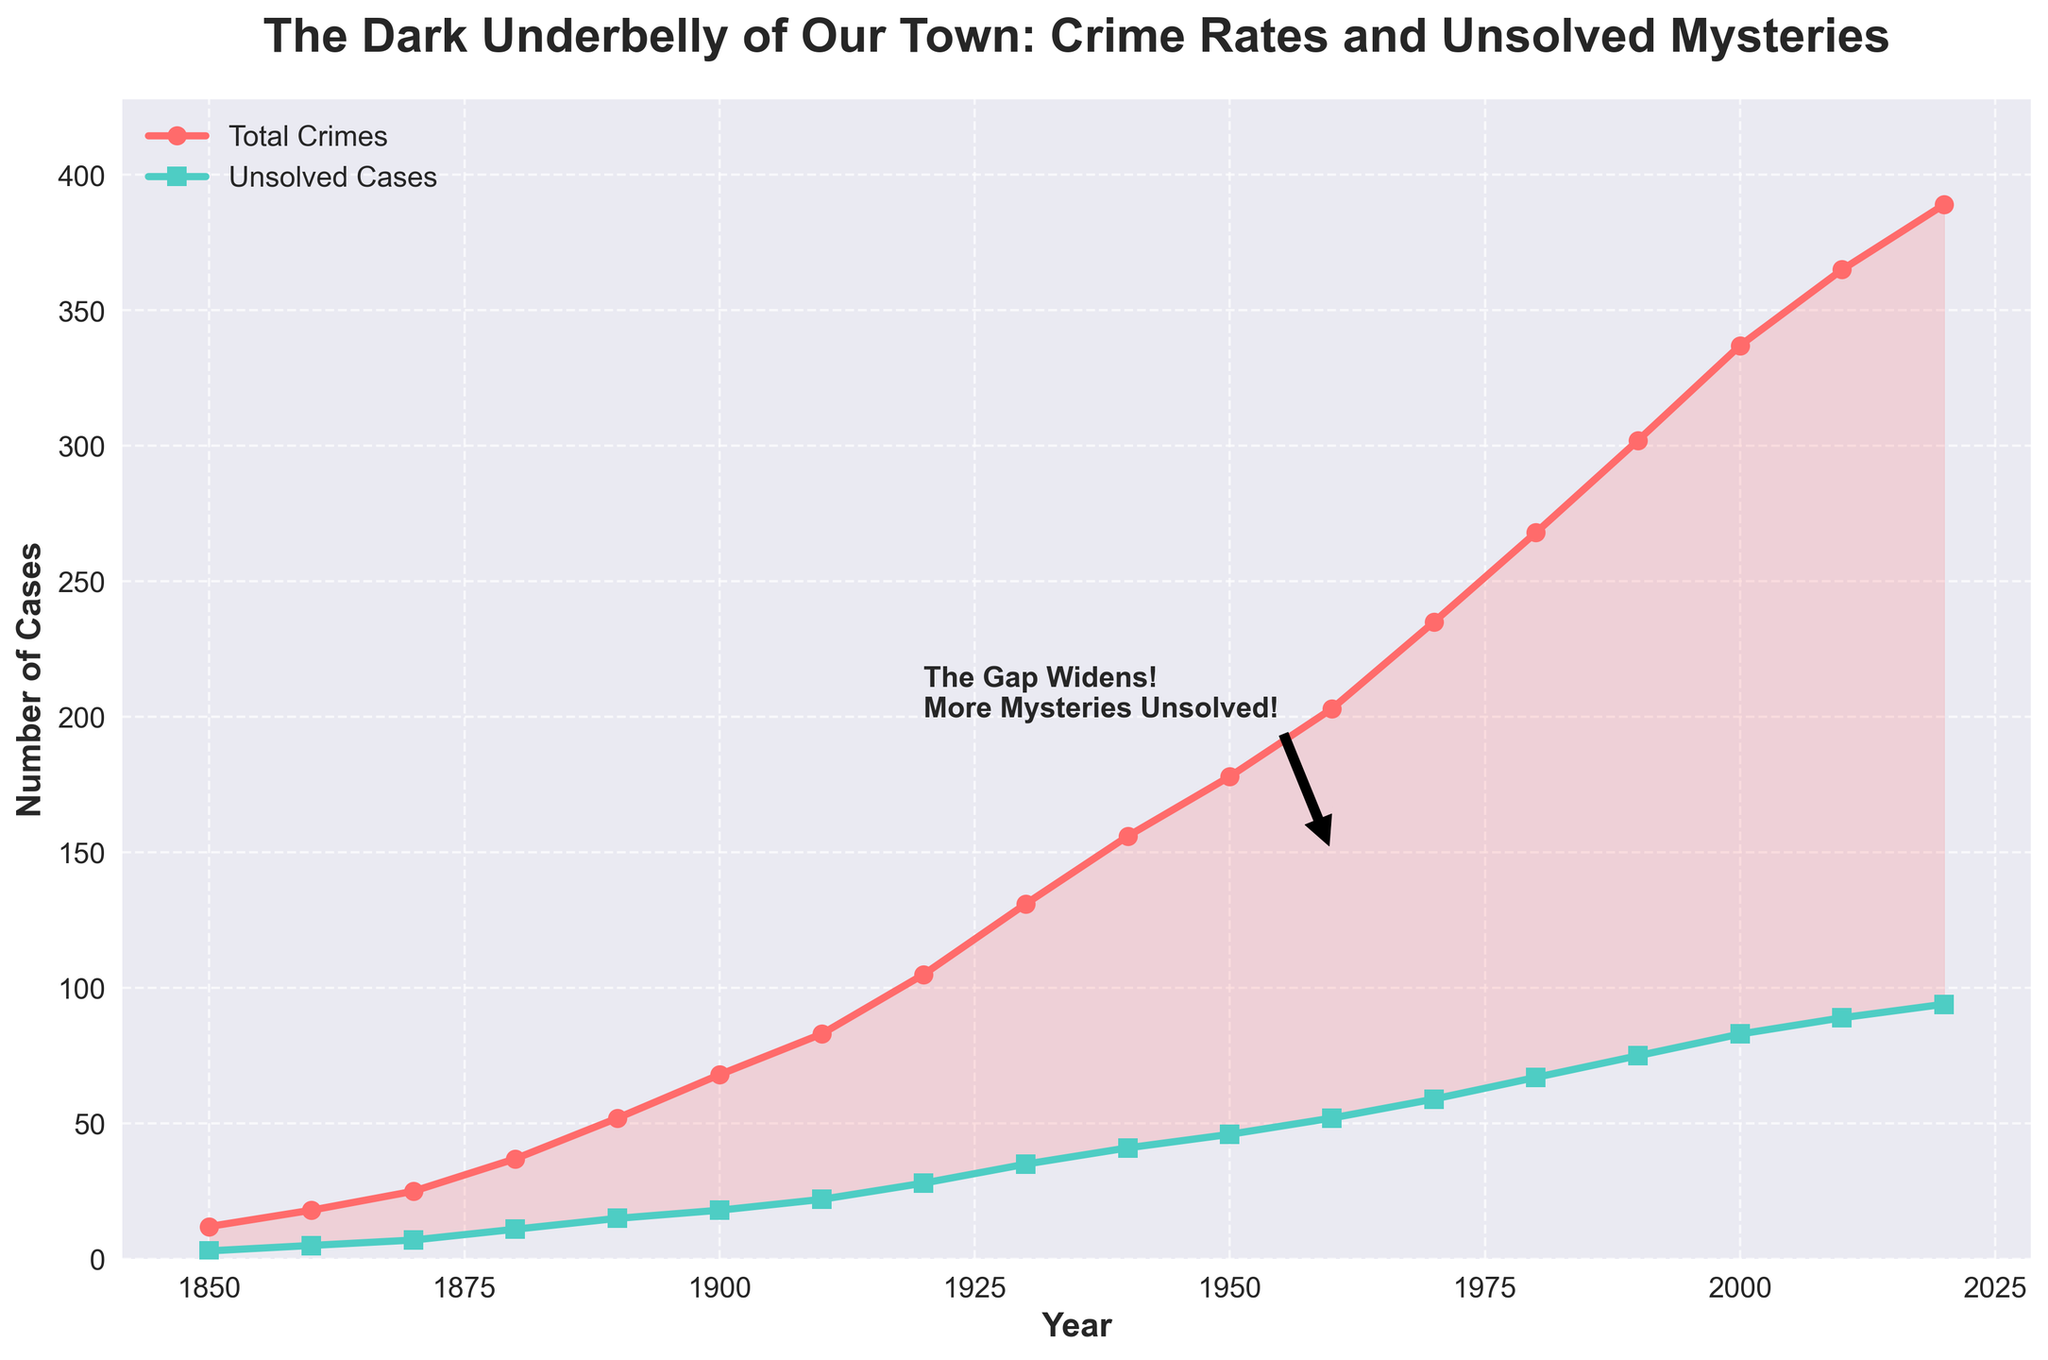What year does the figure highlight with an annotation about widening gaps and unsolved mysteries? The annotation on the figure is placed around the year 1960 and mentions "The Gap Widens! More Mysteries Unsolved!"
Answer: 1960 Compare the number of total crimes in the year 1920 with the year 1930. Which year had more total crimes? The line for total crimes crosses higher in 1930 compared to 1920. The figure shows around 105 total crimes in 1920 and 131 total crimes in 1930.
Answer: 1930 How many unsolved cases were there in 1950 compared to the total number of crimes? The figure shows approximately 178 total crimes and 46 unsolved cases in 1950.
Answer: 46 unsolved cases, 178 total crimes What can you infer about the trend of unsolved cases from 1850 to 2020? The trend shows a steady increase in unsolved cases from 3 in 1850 to 94 in 2020, indicating a growing number of mysteries over time.
Answer: Steady increase What is the approximate difference between total crimes and unsolved cases in the year 2000? In 2000, the number of total crimes is approximately 337, and the number of unsolved cases is around 83. The difference is 337 - 83 = 254.
Answer: 254 What does the shaded area between the two lines represent? The shaded area between the total crimes line and the unsolved cases line represents the number of crimes that were solved each year.
Answer: Solved crimes Which decade observed the highest increase in total crimes? To determine the decade with the highest increase, compare the differences in total crimes between consecutive decades. The biggest jump is between 1990 (302) and 2000 (337), an increase of 35.
Answer: 1990s How does the color coding in the figure help differentiate between total crimes and unsolved cases? The total crimes line is highlighted in red, and the unsolved cases line is highlighted in teal. This color differentiation helps distinguish between the two metrics.
Answer: Red for total crimes, teal for unsolved cases 